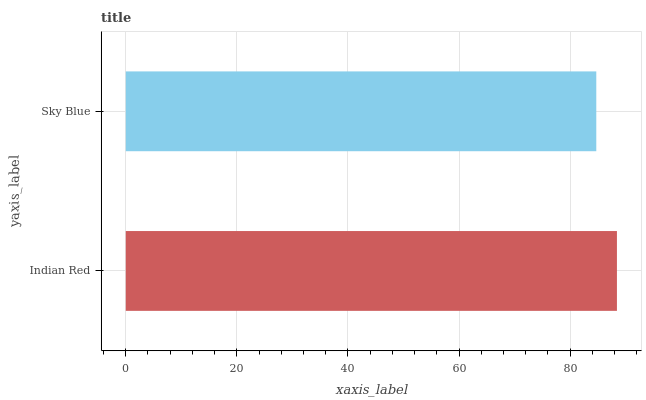Is Sky Blue the minimum?
Answer yes or no. Yes. Is Indian Red the maximum?
Answer yes or no. Yes. Is Sky Blue the maximum?
Answer yes or no. No. Is Indian Red greater than Sky Blue?
Answer yes or no. Yes. Is Sky Blue less than Indian Red?
Answer yes or no. Yes. Is Sky Blue greater than Indian Red?
Answer yes or no. No. Is Indian Red less than Sky Blue?
Answer yes or no. No. Is Indian Red the high median?
Answer yes or no. Yes. Is Sky Blue the low median?
Answer yes or no. Yes. Is Sky Blue the high median?
Answer yes or no. No. Is Indian Red the low median?
Answer yes or no. No. 